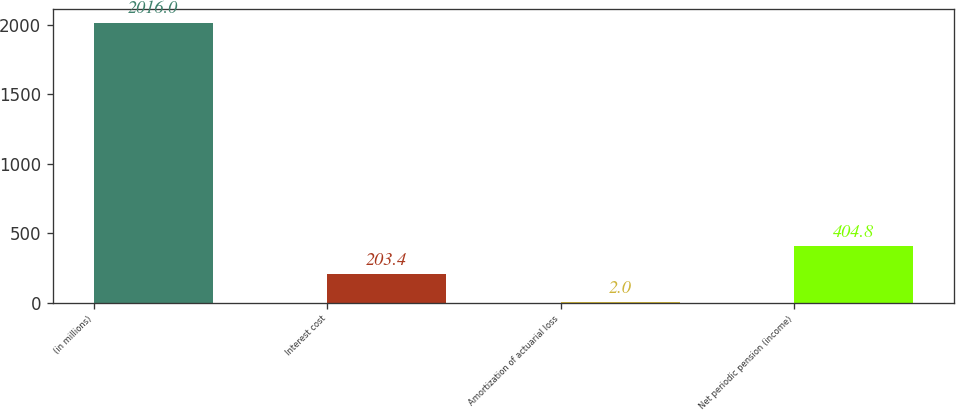<chart> <loc_0><loc_0><loc_500><loc_500><bar_chart><fcel>(in millions)<fcel>Interest cost<fcel>Amortization of actuarial loss<fcel>Net periodic pension (income)<nl><fcel>2016<fcel>203.4<fcel>2<fcel>404.8<nl></chart> 